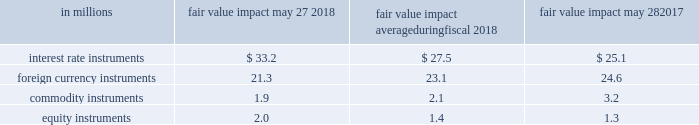Course of business , we actively manage our exposure to these market risks by entering into various hedging transactions , authorized under established policies that place clear controls on these activities .
The counterparties in these transactions are generally highly rated institutions .
We establish credit limits for each counterparty .
Our hedging transactions include but are not limited to a variety of derivative financial instruments .
For information on interest rate , foreign exchange , commodity price , and equity instrument risk , please see note 7 to the consolidated financial statements in item 8 of this report .
Value at risk the estimates in the table below are intended to measure the maximum potential fair value we could lose in one day from adverse changes in market interest rates , foreign exchange rates , commodity prices , and equity prices under normal market conditions .
A monte carlo value-at-risk ( var ) methodology was used to quantify the market risk for our exposures .
The models assumed normal market conditions and used a 95 percent confidence level .
The var calculation used historical interest and foreign exchange rates , and commodity and equity prices from the past year to estimate the potential volatility and correlation of these rates in the future .
The market data were drawn from the riskmetrics 2122 data set .
The calculations are not intended to represent actual losses in fair value that we expect to incur .
Further , since the hedging instrument ( the derivative ) inversely correlates with the underlying exposure , we would expect that any loss or gain in the fair value of our derivatives would be generally offset by an increase or decrease in the fair value of the underlying exposure .
The positions included in the calculations were : debt ; investments ; interest rate swaps ; foreign exchange forwards ; commodity swaps , futures , and options ; and equity instruments .
The calculations do not include the underlying foreign exchange and commodities or equity-related positions that are offset by these market-risk-sensitive instruments .
The table below presents the estimated maximum potential var arising from a one-day loss in fair value for our interest rate , foreign currency , commodity , and equity market-risk-sensitive instruments outstanding as of may 27 , 2018 and may 28 , 2017 , and the average fair value impact during the year ended may 27 , 2018. .

What is the total fair value impact for all instruments as of may 27 , 2018? 
Computations: (((33.2 + 21.3) + 1.9) + 2.0)
Answer: 58.4. 